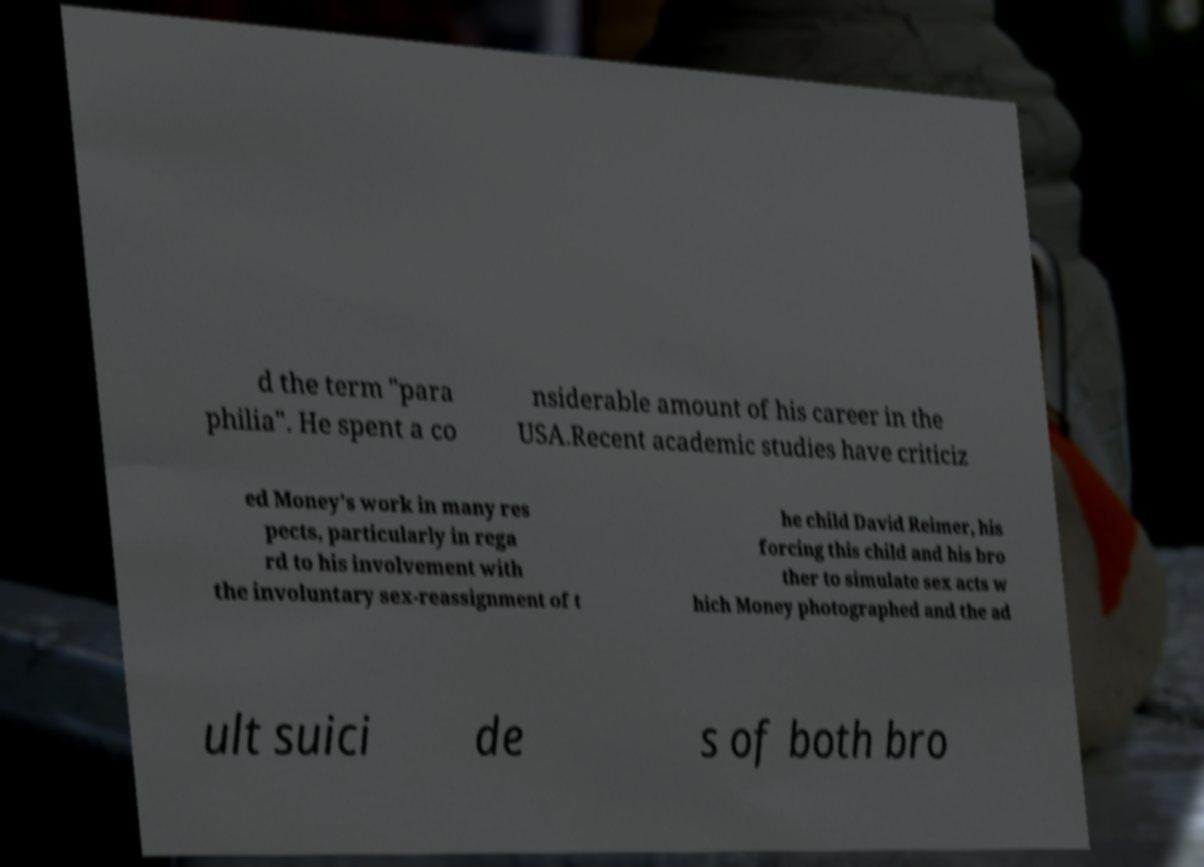What messages or text are displayed in this image? I need them in a readable, typed format. d the term "para philia". He spent a co nsiderable amount of his career in the USA.Recent academic studies have criticiz ed Money's work in many res pects, particularly in rega rd to his involvement with the involuntary sex-reassignment of t he child David Reimer, his forcing this child and his bro ther to simulate sex acts w hich Money photographed and the ad ult suici de s of both bro 